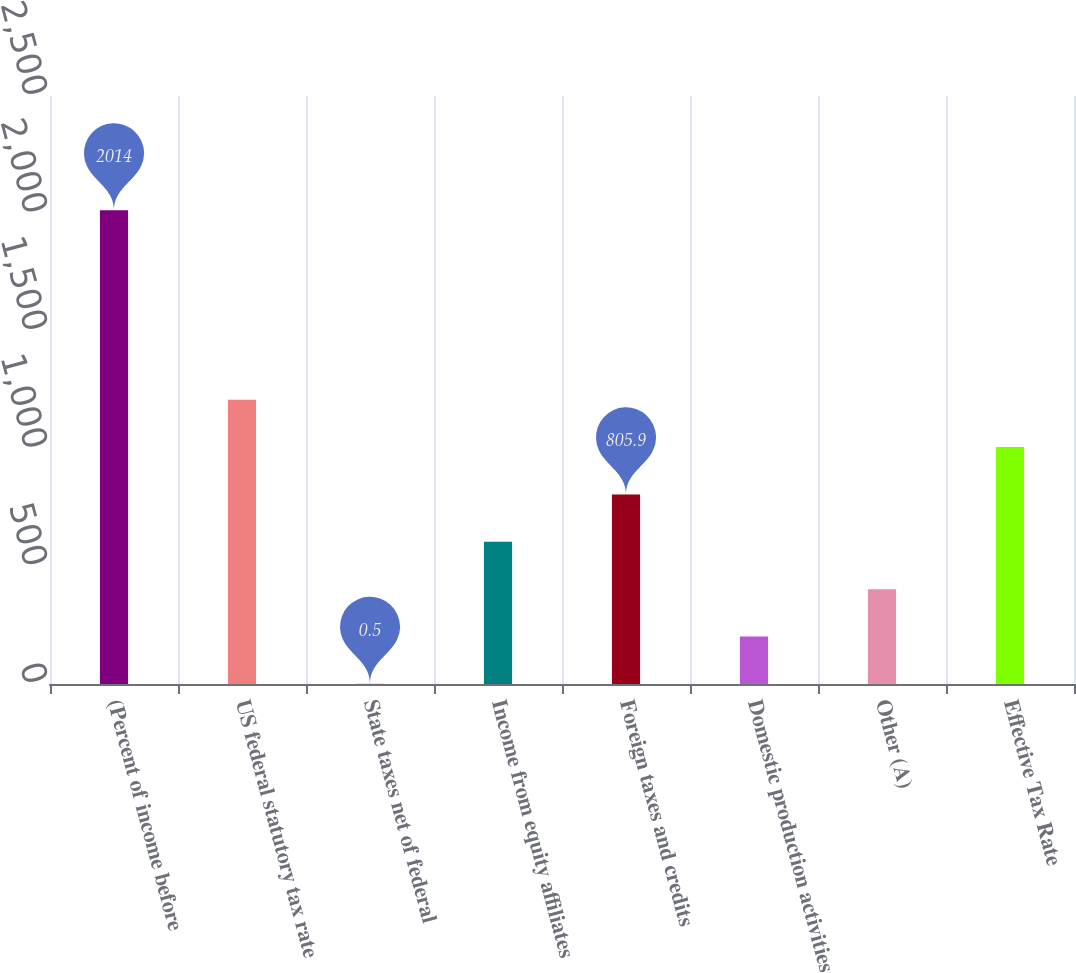Convert chart. <chart><loc_0><loc_0><loc_500><loc_500><bar_chart><fcel>(Percent of income before<fcel>US federal statutory tax rate<fcel>State taxes net of federal<fcel>Income from equity affiliates<fcel>Foreign taxes and credits<fcel>Domestic production activities<fcel>Other (A)<fcel>Effective Tax Rate<nl><fcel>2014<fcel>1208.6<fcel>0.5<fcel>604.55<fcel>805.9<fcel>201.85<fcel>403.2<fcel>1007.25<nl></chart> 